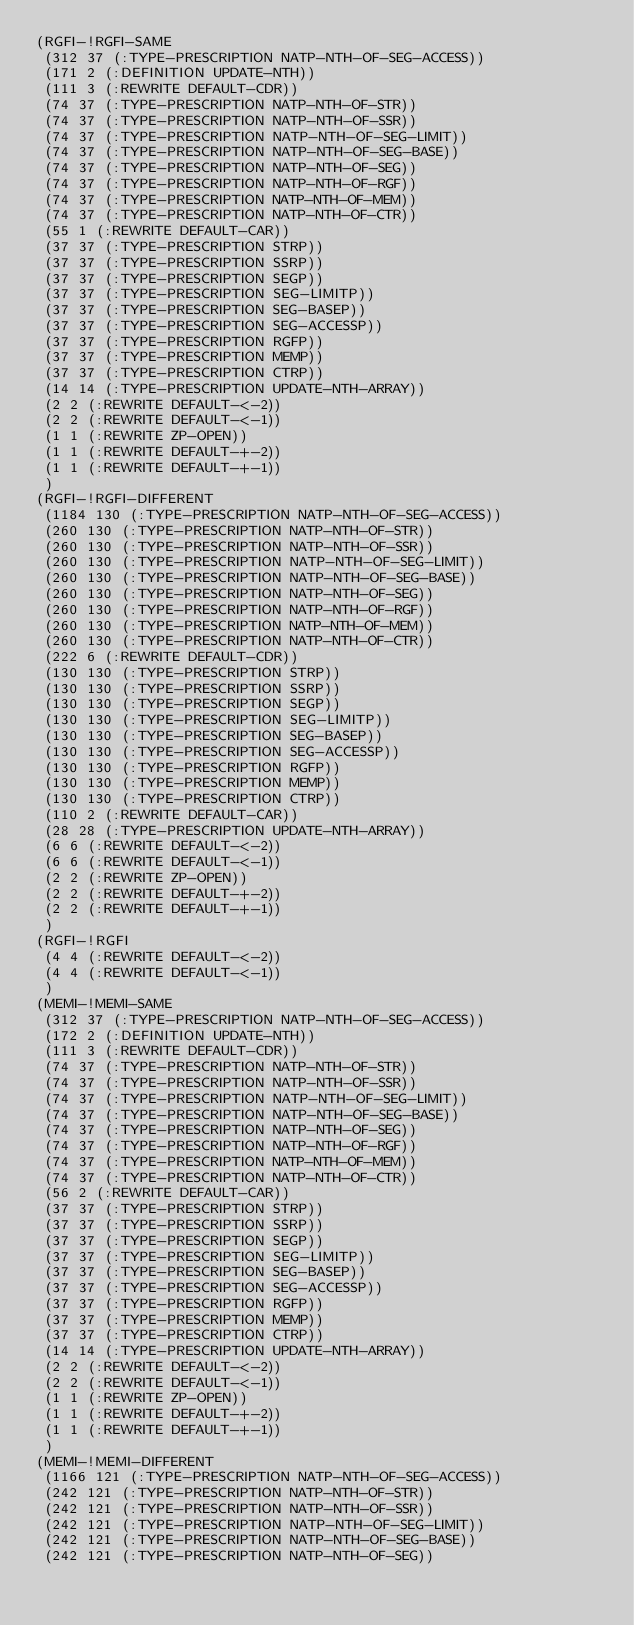<code> <loc_0><loc_0><loc_500><loc_500><_Lisp_>(RGFI-!RGFI-SAME
 (312 37 (:TYPE-PRESCRIPTION NATP-NTH-OF-SEG-ACCESS))
 (171 2 (:DEFINITION UPDATE-NTH))
 (111 3 (:REWRITE DEFAULT-CDR))
 (74 37 (:TYPE-PRESCRIPTION NATP-NTH-OF-STR))
 (74 37 (:TYPE-PRESCRIPTION NATP-NTH-OF-SSR))
 (74 37 (:TYPE-PRESCRIPTION NATP-NTH-OF-SEG-LIMIT))
 (74 37 (:TYPE-PRESCRIPTION NATP-NTH-OF-SEG-BASE))
 (74 37 (:TYPE-PRESCRIPTION NATP-NTH-OF-SEG))
 (74 37 (:TYPE-PRESCRIPTION NATP-NTH-OF-RGF))
 (74 37 (:TYPE-PRESCRIPTION NATP-NTH-OF-MEM))
 (74 37 (:TYPE-PRESCRIPTION NATP-NTH-OF-CTR))
 (55 1 (:REWRITE DEFAULT-CAR))
 (37 37 (:TYPE-PRESCRIPTION STRP))
 (37 37 (:TYPE-PRESCRIPTION SSRP))
 (37 37 (:TYPE-PRESCRIPTION SEGP))
 (37 37 (:TYPE-PRESCRIPTION SEG-LIMITP))
 (37 37 (:TYPE-PRESCRIPTION SEG-BASEP))
 (37 37 (:TYPE-PRESCRIPTION SEG-ACCESSP))
 (37 37 (:TYPE-PRESCRIPTION RGFP))
 (37 37 (:TYPE-PRESCRIPTION MEMP))
 (37 37 (:TYPE-PRESCRIPTION CTRP))
 (14 14 (:TYPE-PRESCRIPTION UPDATE-NTH-ARRAY))
 (2 2 (:REWRITE DEFAULT-<-2))
 (2 2 (:REWRITE DEFAULT-<-1))
 (1 1 (:REWRITE ZP-OPEN))
 (1 1 (:REWRITE DEFAULT-+-2))
 (1 1 (:REWRITE DEFAULT-+-1))
 )
(RGFI-!RGFI-DIFFERENT
 (1184 130 (:TYPE-PRESCRIPTION NATP-NTH-OF-SEG-ACCESS))
 (260 130 (:TYPE-PRESCRIPTION NATP-NTH-OF-STR))
 (260 130 (:TYPE-PRESCRIPTION NATP-NTH-OF-SSR))
 (260 130 (:TYPE-PRESCRIPTION NATP-NTH-OF-SEG-LIMIT))
 (260 130 (:TYPE-PRESCRIPTION NATP-NTH-OF-SEG-BASE))
 (260 130 (:TYPE-PRESCRIPTION NATP-NTH-OF-SEG))
 (260 130 (:TYPE-PRESCRIPTION NATP-NTH-OF-RGF))
 (260 130 (:TYPE-PRESCRIPTION NATP-NTH-OF-MEM))
 (260 130 (:TYPE-PRESCRIPTION NATP-NTH-OF-CTR))
 (222 6 (:REWRITE DEFAULT-CDR))
 (130 130 (:TYPE-PRESCRIPTION STRP))
 (130 130 (:TYPE-PRESCRIPTION SSRP))
 (130 130 (:TYPE-PRESCRIPTION SEGP))
 (130 130 (:TYPE-PRESCRIPTION SEG-LIMITP))
 (130 130 (:TYPE-PRESCRIPTION SEG-BASEP))
 (130 130 (:TYPE-PRESCRIPTION SEG-ACCESSP))
 (130 130 (:TYPE-PRESCRIPTION RGFP))
 (130 130 (:TYPE-PRESCRIPTION MEMP))
 (130 130 (:TYPE-PRESCRIPTION CTRP))
 (110 2 (:REWRITE DEFAULT-CAR))
 (28 28 (:TYPE-PRESCRIPTION UPDATE-NTH-ARRAY))
 (6 6 (:REWRITE DEFAULT-<-2))
 (6 6 (:REWRITE DEFAULT-<-1))
 (2 2 (:REWRITE ZP-OPEN))
 (2 2 (:REWRITE DEFAULT-+-2))
 (2 2 (:REWRITE DEFAULT-+-1))
 )
(RGFI-!RGFI
 (4 4 (:REWRITE DEFAULT-<-2))
 (4 4 (:REWRITE DEFAULT-<-1))
 )
(MEMI-!MEMI-SAME
 (312 37 (:TYPE-PRESCRIPTION NATP-NTH-OF-SEG-ACCESS))
 (172 2 (:DEFINITION UPDATE-NTH))
 (111 3 (:REWRITE DEFAULT-CDR))
 (74 37 (:TYPE-PRESCRIPTION NATP-NTH-OF-STR))
 (74 37 (:TYPE-PRESCRIPTION NATP-NTH-OF-SSR))
 (74 37 (:TYPE-PRESCRIPTION NATP-NTH-OF-SEG-LIMIT))
 (74 37 (:TYPE-PRESCRIPTION NATP-NTH-OF-SEG-BASE))
 (74 37 (:TYPE-PRESCRIPTION NATP-NTH-OF-SEG))
 (74 37 (:TYPE-PRESCRIPTION NATP-NTH-OF-RGF))
 (74 37 (:TYPE-PRESCRIPTION NATP-NTH-OF-MEM))
 (74 37 (:TYPE-PRESCRIPTION NATP-NTH-OF-CTR))
 (56 2 (:REWRITE DEFAULT-CAR))
 (37 37 (:TYPE-PRESCRIPTION STRP))
 (37 37 (:TYPE-PRESCRIPTION SSRP))
 (37 37 (:TYPE-PRESCRIPTION SEGP))
 (37 37 (:TYPE-PRESCRIPTION SEG-LIMITP))
 (37 37 (:TYPE-PRESCRIPTION SEG-BASEP))
 (37 37 (:TYPE-PRESCRIPTION SEG-ACCESSP))
 (37 37 (:TYPE-PRESCRIPTION RGFP))
 (37 37 (:TYPE-PRESCRIPTION MEMP))
 (37 37 (:TYPE-PRESCRIPTION CTRP))
 (14 14 (:TYPE-PRESCRIPTION UPDATE-NTH-ARRAY))
 (2 2 (:REWRITE DEFAULT-<-2))
 (2 2 (:REWRITE DEFAULT-<-1))
 (1 1 (:REWRITE ZP-OPEN))
 (1 1 (:REWRITE DEFAULT-+-2))
 (1 1 (:REWRITE DEFAULT-+-1))
 )
(MEMI-!MEMI-DIFFERENT
 (1166 121 (:TYPE-PRESCRIPTION NATP-NTH-OF-SEG-ACCESS))
 (242 121 (:TYPE-PRESCRIPTION NATP-NTH-OF-STR))
 (242 121 (:TYPE-PRESCRIPTION NATP-NTH-OF-SSR))
 (242 121 (:TYPE-PRESCRIPTION NATP-NTH-OF-SEG-LIMIT))
 (242 121 (:TYPE-PRESCRIPTION NATP-NTH-OF-SEG-BASE))
 (242 121 (:TYPE-PRESCRIPTION NATP-NTH-OF-SEG))</code> 